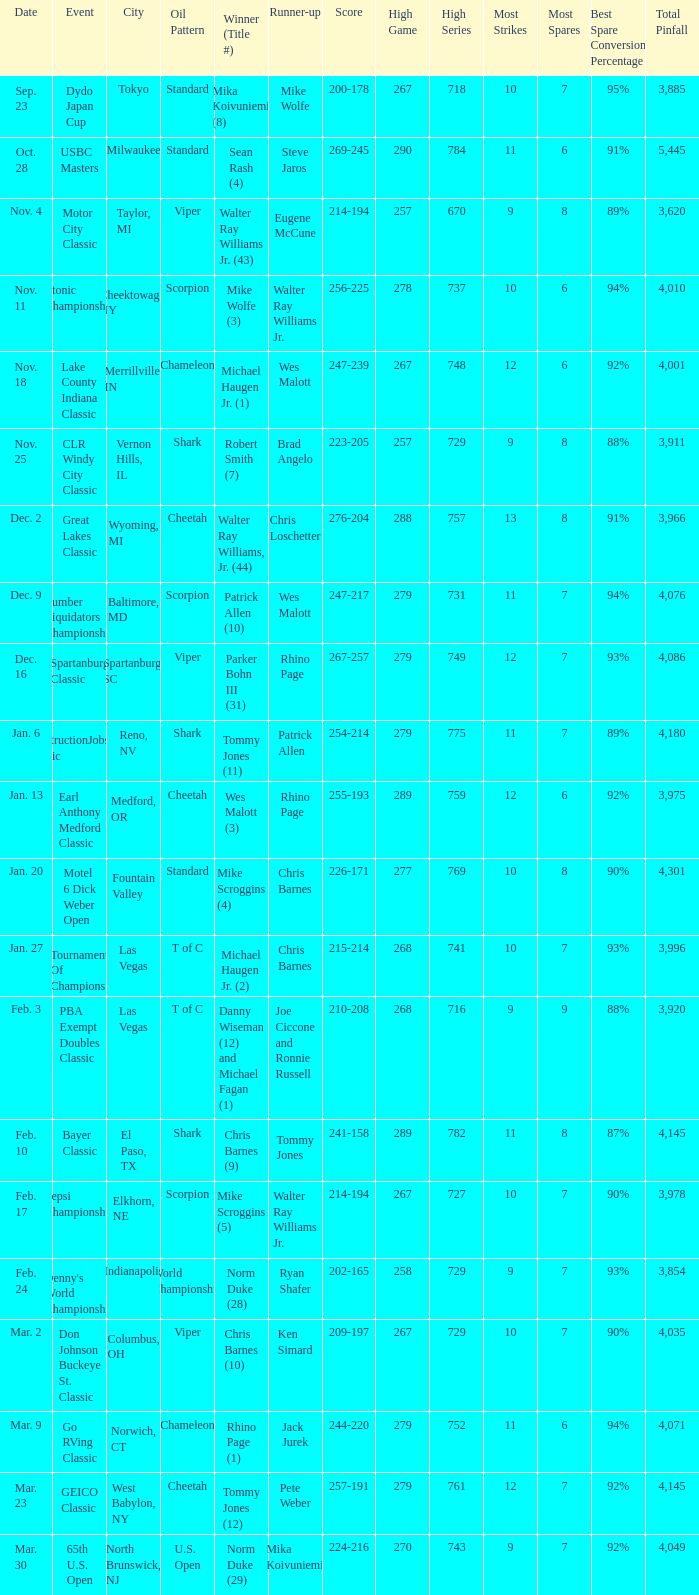Which Score has an Event of constructionjobs.com classic? 254-214. 